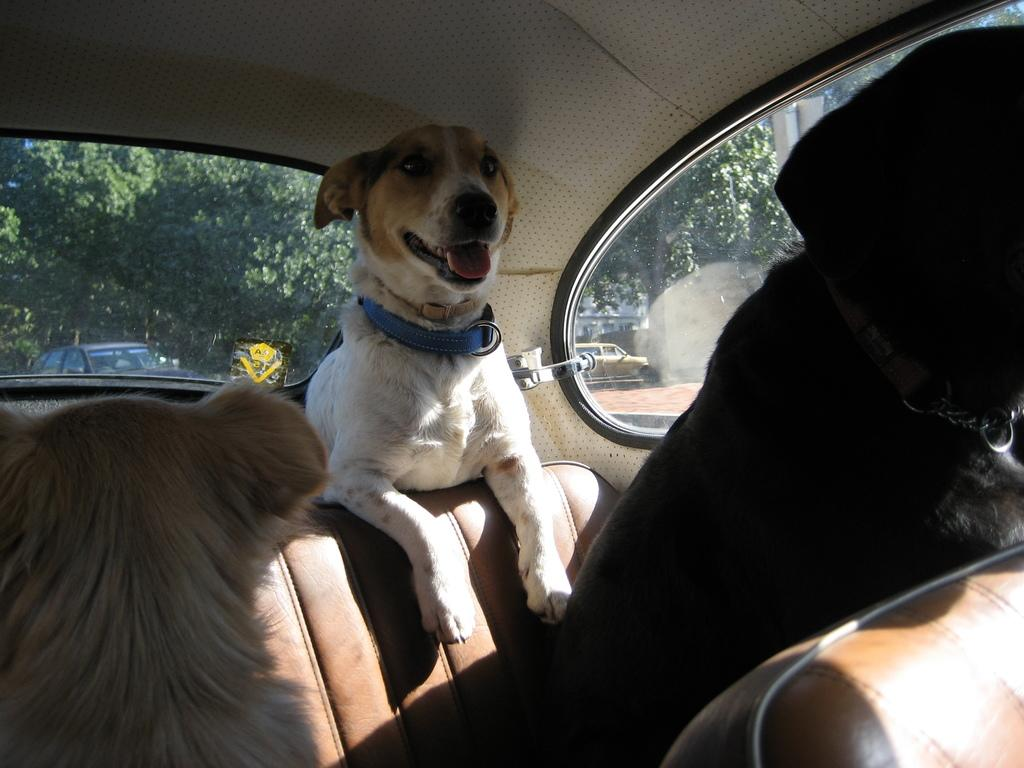How many dogs are in the car in the image? There are three dogs in the car in the image. What can be seen in the background of the image? Trees are visible at the back side of the image. What type of ink can be seen spilled on the car's seat in the image? There is no ink spilled on the car's seat in the image; it only shows three dogs in the car. 